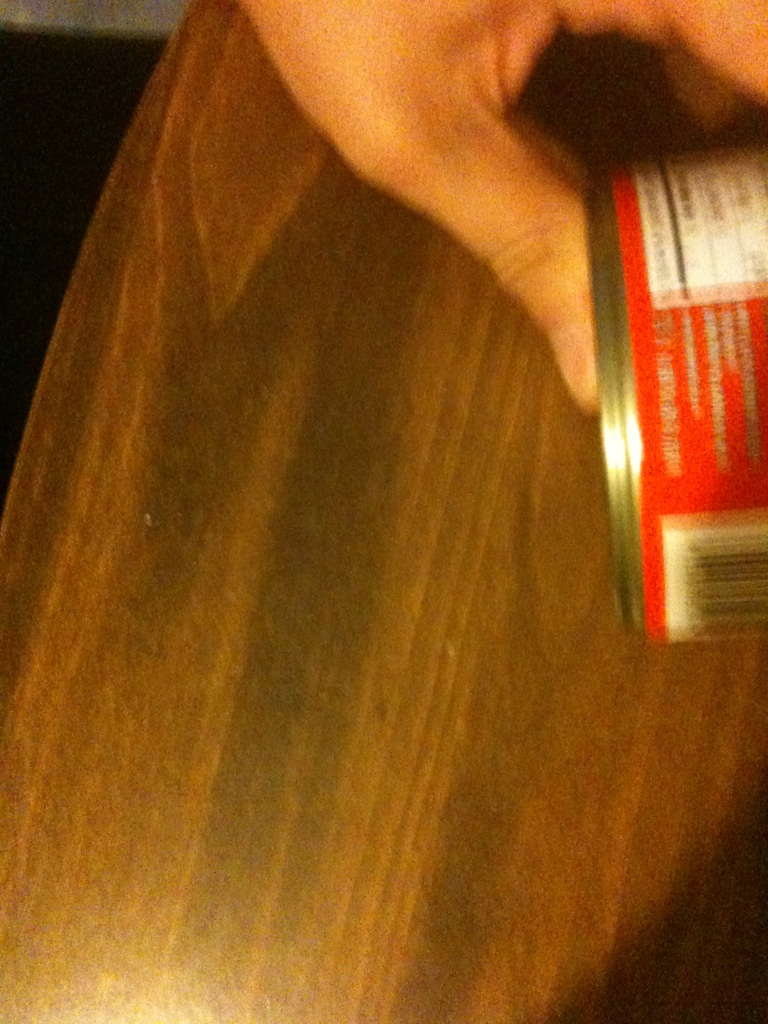Can you tell what might be written on the label of the can? The image is blurry, but there seems to be red and white coloring on the label, possibly indicating a common brand color scheme. Unfortunately, the text itself is not clear enough to read accurately. 